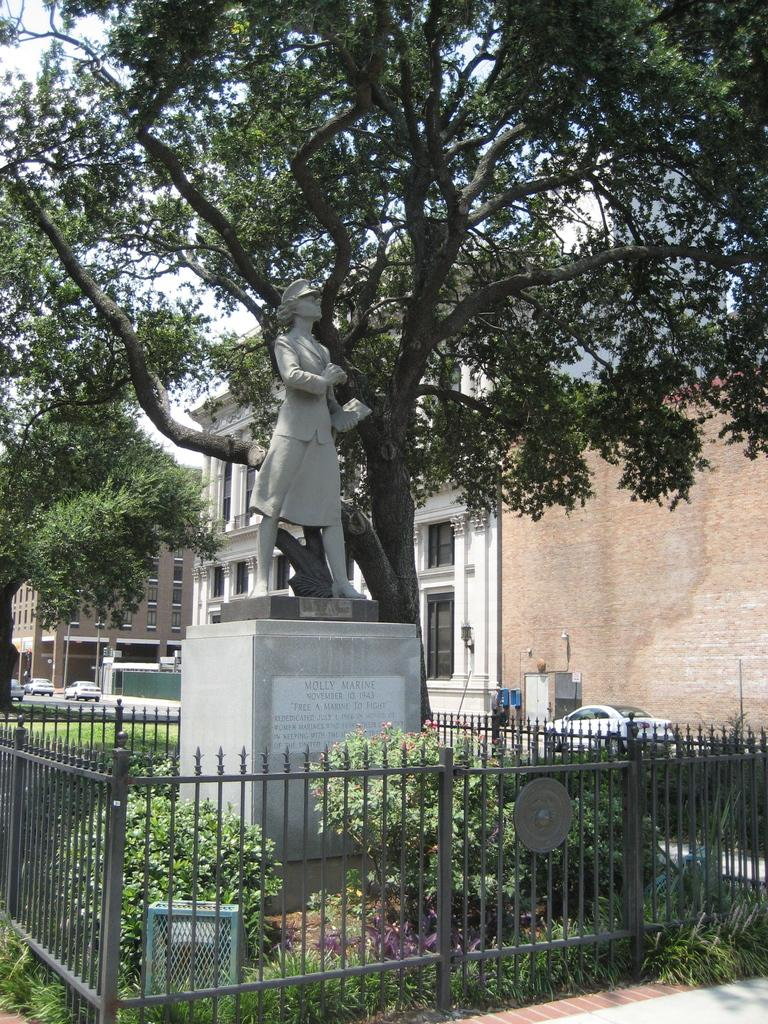<image>
Relay a brief, clear account of the picture shown. A statue of a woman in a uniform, her name was Molly Marine. 